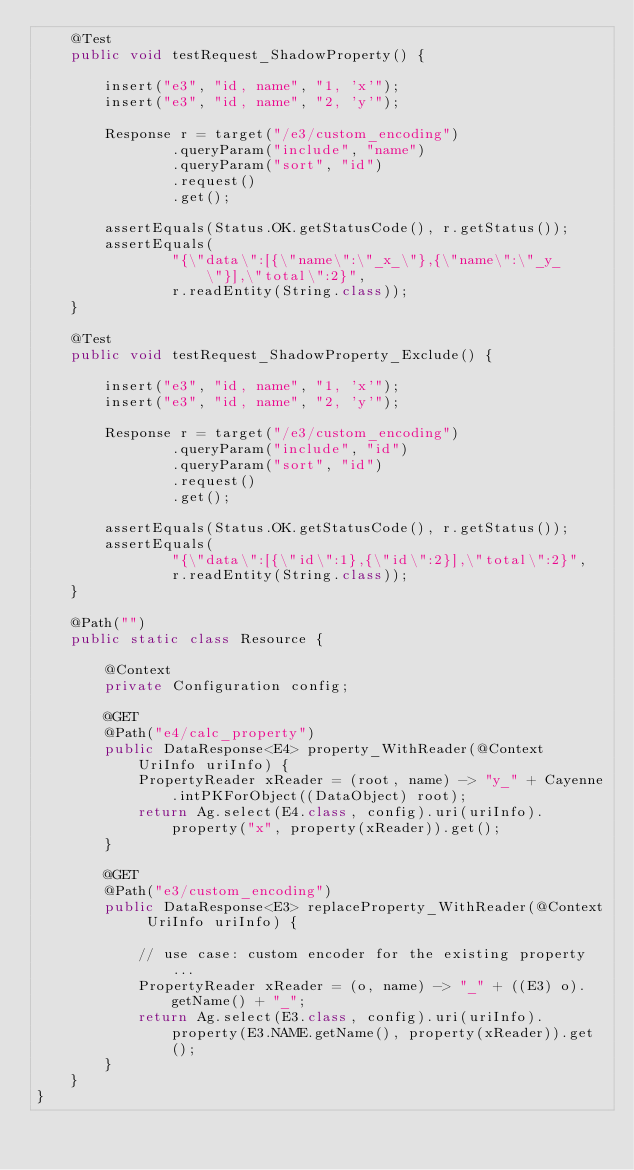Convert code to text. <code><loc_0><loc_0><loc_500><loc_500><_Java_>    @Test
    public void testRequest_ShadowProperty() {

        insert("e3", "id, name", "1, 'x'");
        insert("e3", "id, name", "2, 'y'");

        Response r = target("/e3/custom_encoding")
                .queryParam("include", "name")
                .queryParam("sort", "id")
                .request()
                .get();

        assertEquals(Status.OK.getStatusCode(), r.getStatus());
        assertEquals(
                "{\"data\":[{\"name\":\"_x_\"},{\"name\":\"_y_\"}],\"total\":2}",
                r.readEntity(String.class));
    }

    @Test
    public void testRequest_ShadowProperty_Exclude() {

        insert("e3", "id, name", "1, 'x'");
        insert("e3", "id, name", "2, 'y'");

        Response r = target("/e3/custom_encoding")
                .queryParam("include", "id")
                .queryParam("sort", "id")
                .request()
                .get();

        assertEquals(Status.OK.getStatusCode(), r.getStatus());
        assertEquals(
                "{\"data\":[{\"id\":1},{\"id\":2}],\"total\":2}",
                r.readEntity(String.class));
    }

    @Path("")
    public static class Resource {

        @Context
        private Configuration config;

        @GET
        @Path("e4/calc_property")
        public DataResponse<E4> property_WithReader(@Context UriInfo uriInfo) {
            PropertyReader xReader = (root, name) -> "y_" + Cayenne.intPKForObject((DataObject) root);
            return Ag.select(E4.class, config).uri(uriInfo).property("x", property(xReader)).get();
        }

        @GET
        @Path("e3/custom_encoding")
        public DataResponse<E3> replaceProperty_WithReader(@Context UriInfo uriInfo) {

            // use case: custom encoder for the existing property...
            PropertyReader xReader = (o, name) -> "_" + ((E3) o).getName() + "_";
            return Ag.select(E3.class, config).uri(uriInfo).property(E3.NAME.getName(), property(xReader)).get();
        }
    }
}
</code> 